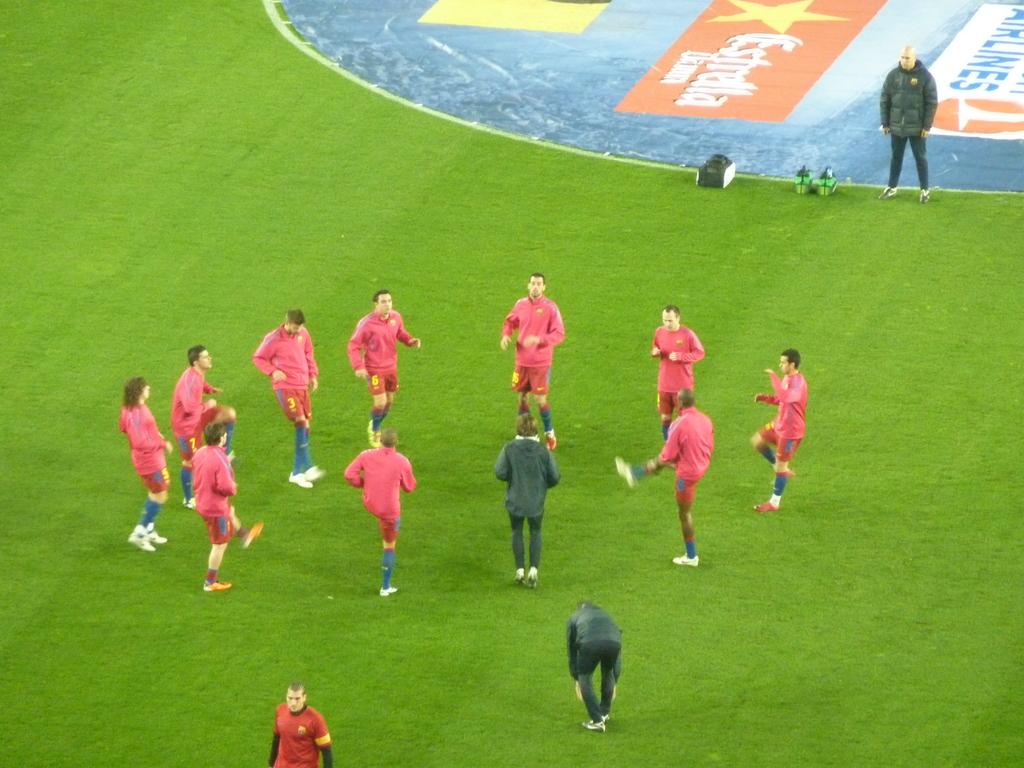What is written in blue?
Provide a succinct answer. Airlines. 